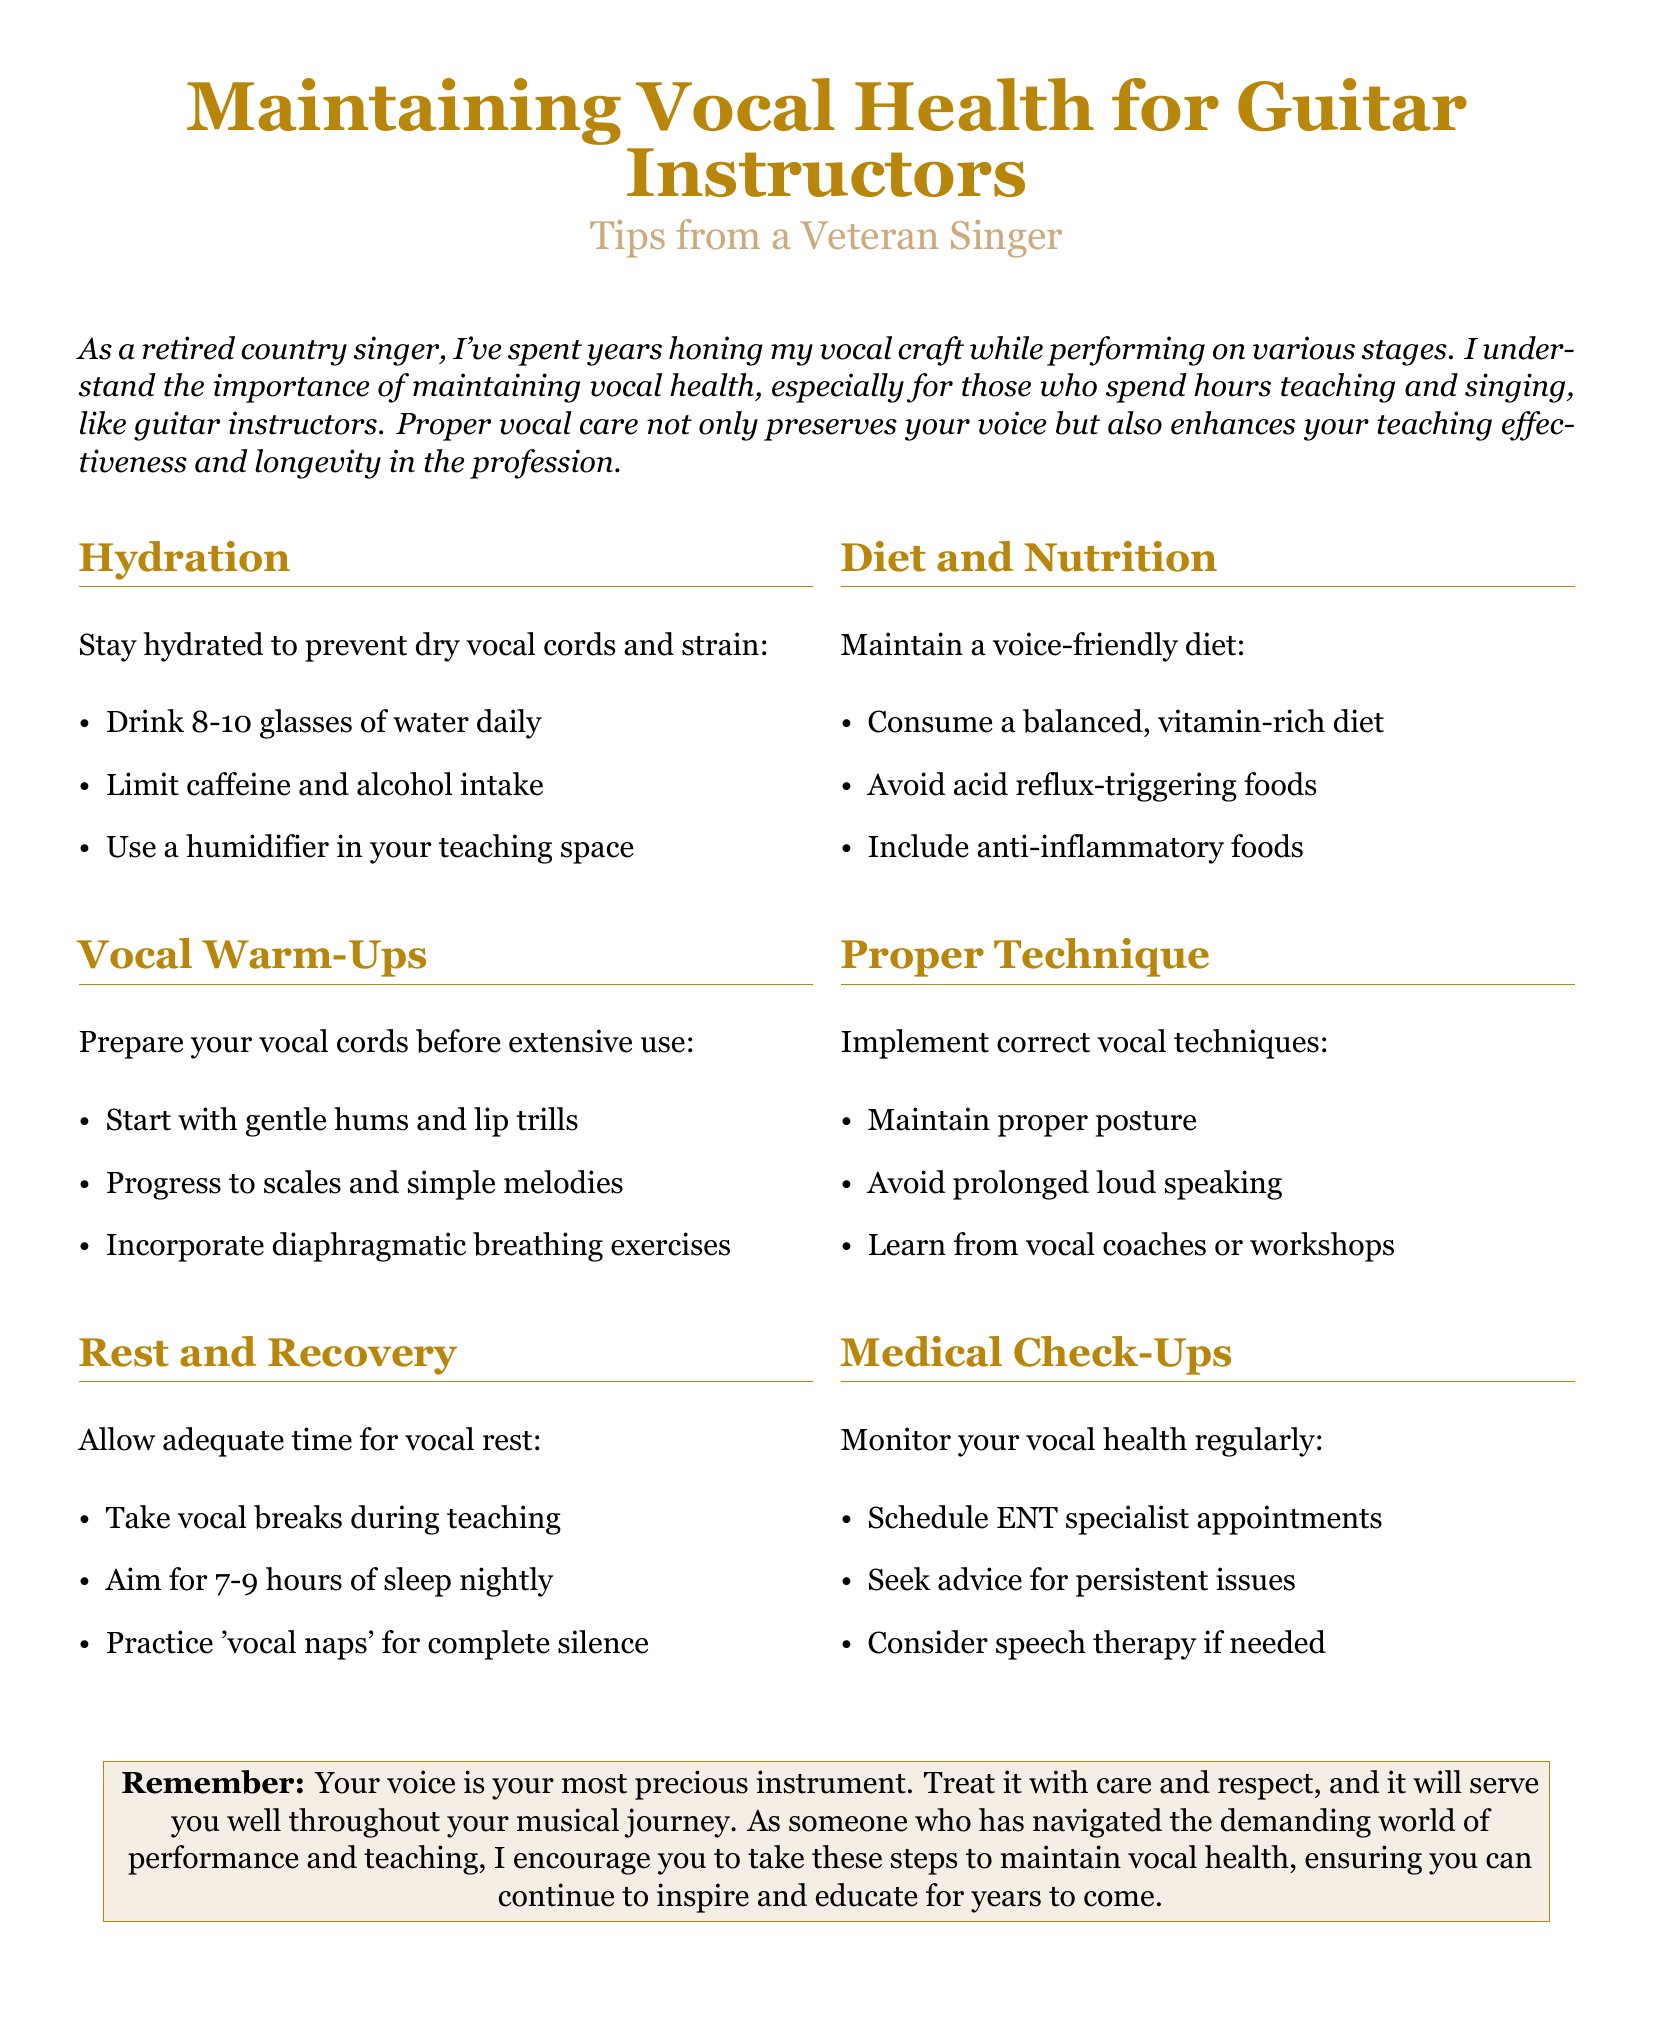What is the recommended daily water intake? The document states to drink 8-10 glasses of water daily to stay hydrated.
Answer: 8-10 glasses What are two vocal warm-up activities mentioned? The document lists gentle hums and lip trills as part of vocal warm-ups.
Answer: gentle hums and lip trills How many hours of sleep should one aim for nightly? The document suggests aiming for 7-9 hours of sleep nightly for vocal rest.
Answer: 7-9 hours What type of foods should be avoided to prevent acid reflux? The document advises avoiding acid reflux-triggering foods as part of a voice-friendly diet.
Answer: acid reflux-triggering foods What is an example of a proper vocal technique? The document suggests maintaining proper posture as a technique to implement.
Answer: proper posture How often should you schedule ENT specialist appointments? The document recommends monitoring vocal health regularly and scheduling appointments with an ENT specialist.
Answer: regularly What is one suggestion for incorporating vocal rest during teaching? The document suggests taking vocal breaks during teaching to allow vocal rest.
Answer: vocal breaks What does the document emphasize about your voice? The document mentions treating your voice with care and respect as it is your most precious instrument.
Answer: most precious instrument 